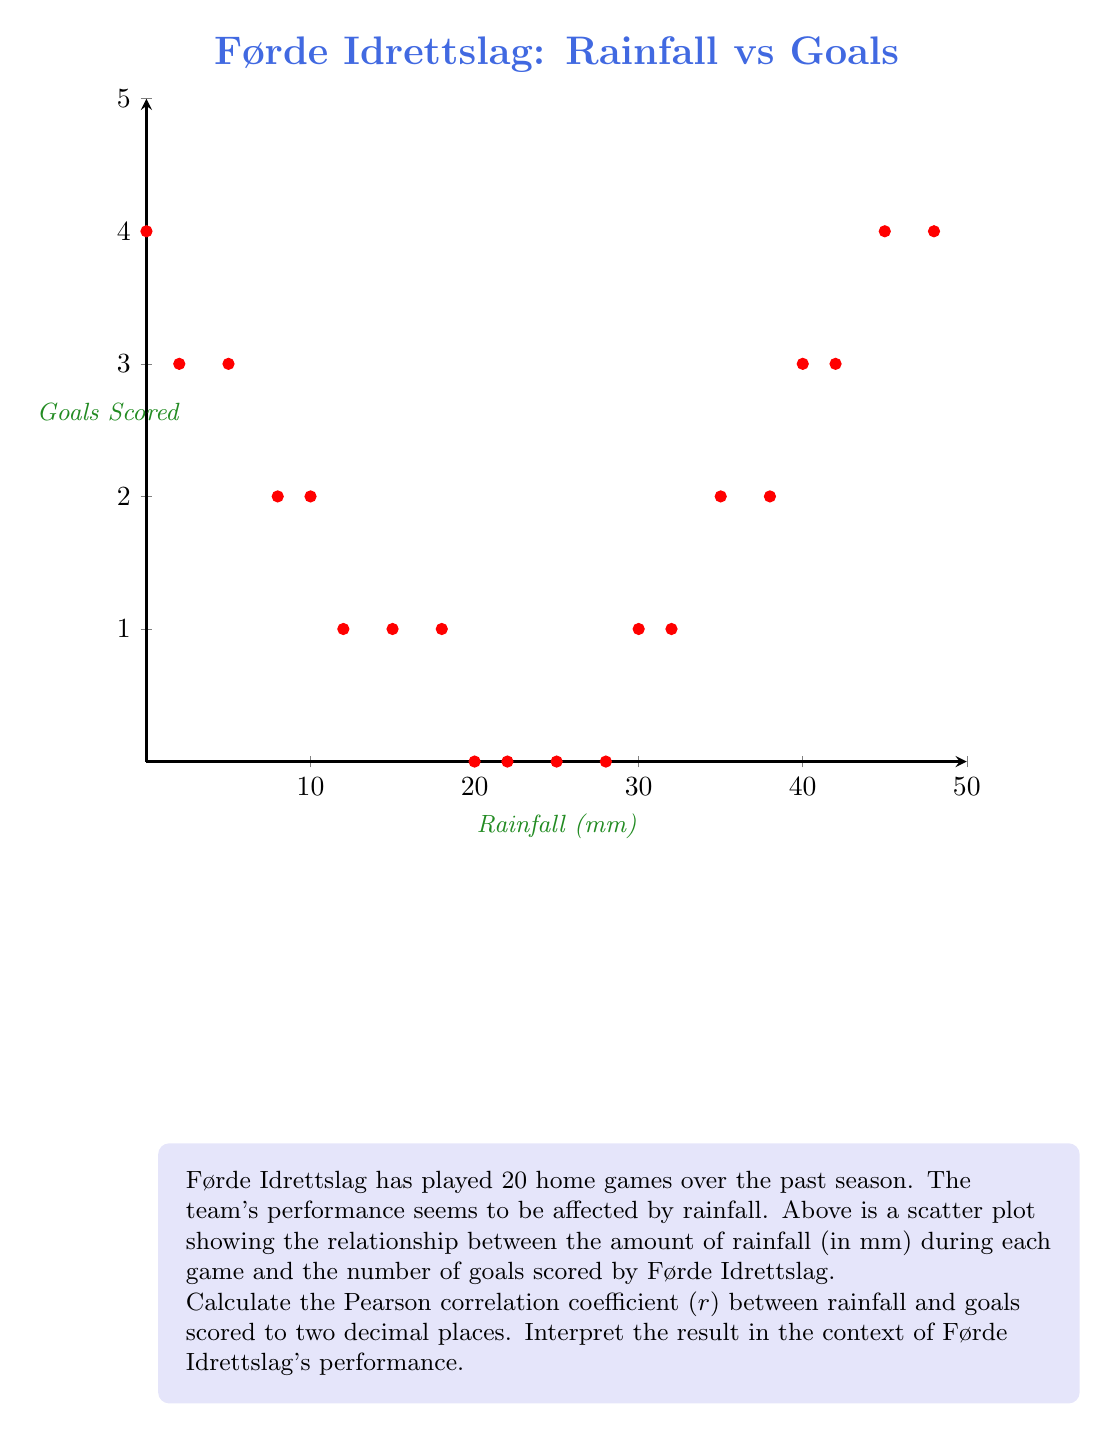Help me with this question. To calculate the Pearson correlation coefficient, we'll follow these steps:

1) First, we need to calculate the means of x (rainfall) and y (goals):

   $\bar{x} = \frac{\sum x_i}{n} = \frac{450}{20} = 22.5$ mm
   $\bar{y} = \frac{\sum y_i}{n} = \frac{37}{20} = 1.85$ goals

2) Next, we calculate the sums needed for the correlation formula:

   $\sum (x_i - \bar{x})(y_i - \bar{y})$
   $\sum (x_i - \bar{x})^2$
   $\sum (y_i - \bar{y})^2$

3) The correlation coefficient is given by:

   $$r = \frac{\sum (x_i - \bar{x})(y_i - \bar{y})}{\sqrt{\sum (x_i - \bar{x})^2 \sum (y_i - \bar{y})^2}}$$

4) Calculating these sums (rounded to two decimal places):

   $\sum (x_i - \bar{x})(y_i - \bar{y}) = -19.25$
   $\sum (x_i - \bar{x})^2 = 4556.25$
   $\sum (y_i - \bar{y})^2 = 28.55$

5) Plugging these values into the formula:

   $$r = \frac{-19.25}{\sqrt{4556.25 \times 28.55}} = -0.06$$

6) Interpretation: The correlation coefficient of -0.06 indicates a very weak negative correlation between rainfall and goals scored. This suggests that there's almost no linear relationship between the amount of rainfall and Førde Idrettslag's goal-scoring performance in home games. The slightly negative value implies a very slight tendency for goal-scoring to decrease as rainfall increases, but this relationship is not strong enough to be considered significant.
Answer: $r = -0.06$, indicating a very weak negative correlation between rainfall and goals scored. 